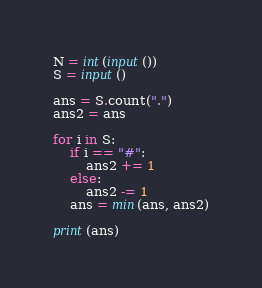<code> <loc_0><loc_0><loc_500><loc_500><_Python_>N = int(input())
S = input()

ans = S.count(".")
ans2 = ans

for i in S:
    if i == "#":
        ans2 += 1
    else:
        ans2 -= 1
    ans = min(ans, ans2)

print(ans)</code> 